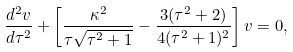<formula> <loc_0><loc_0><loc_500><loc_500>\frac { d ^ { 2 } v } { d \tau ^ { 2 } } + \left [ \frac { \kappa ^ { 2 } } { \tau \sqrt { \tau ^ { 2 } + 1 } } - \frac { 3 ( \tau ^ { 2 } + 2 ) } { 4 ( \tau ^ { 2 } + 1 ) ^ { 2 } } \right ] v = 0 ,</formula> 